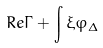<formula> <loc_0><loc_0><loc_500><loc_500>R e \Gamma + \int \xi \varphi _ { \Delta }</formula> 